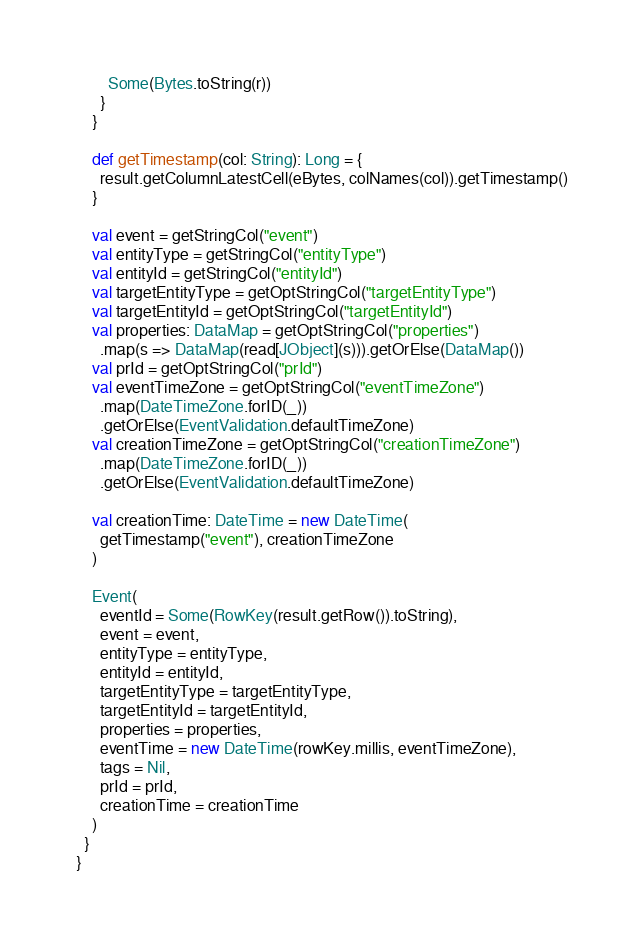Convert code to text. <code><loc_0><loc_0><loc_500><loc_500><_Scala_>        Some(Bytes.toString(r))
      }
    }

    def getTimestamp(col: String): Long = {
      result.getColumnLatestCell(eBytes, colNames(col)).getTimestamp()
    }

    val event = getStringCol("event")
    val entityType = getStringCol("entityType")
    val entityId = getStringCol("entityId")
    val targetEntityType = getOptStringCol("targetEntityType")
    val targetEntityId = getOptStringCol("targetEntityId")
    val properties: DataMap = getOptStringCol("properties")
      .map(s => DataMap(read[JObject](s))).getOrElse(DataMap())
    val prId = getOptStringCol("prId")
    val eventTimeZone = getOptStringCol("eventTimeZone")
      .map(DateTimeZone.forID(_))
      .getOrElse(EventValidation.defaultTimeZone)
    val creationTimeZone = getOptStringCol("creationTimeZone")
      .map(DateTimeZone.forID(_))
      .getOrElse(EventValidation.defaultTimeZone)

    val creationTime: DateTime = new DateTime(
      getTimestamp("event"), creationTimeZone
    )

    Event(
      eventId = Some(RowKey(result.getRow()).toString),
      event = event,
      entityType = entityType,
      entityId = entityId,
      targetEntityType = targetEntityType,
      targetEntityId = targetEntityId,
      properties = properties,
      eventTime = new DateTime(rowKey.millis, eventTimeZone),
      tags = Nil,
      prId = prId,
      creationTime = creationTime
    )
  }
}
</code> 